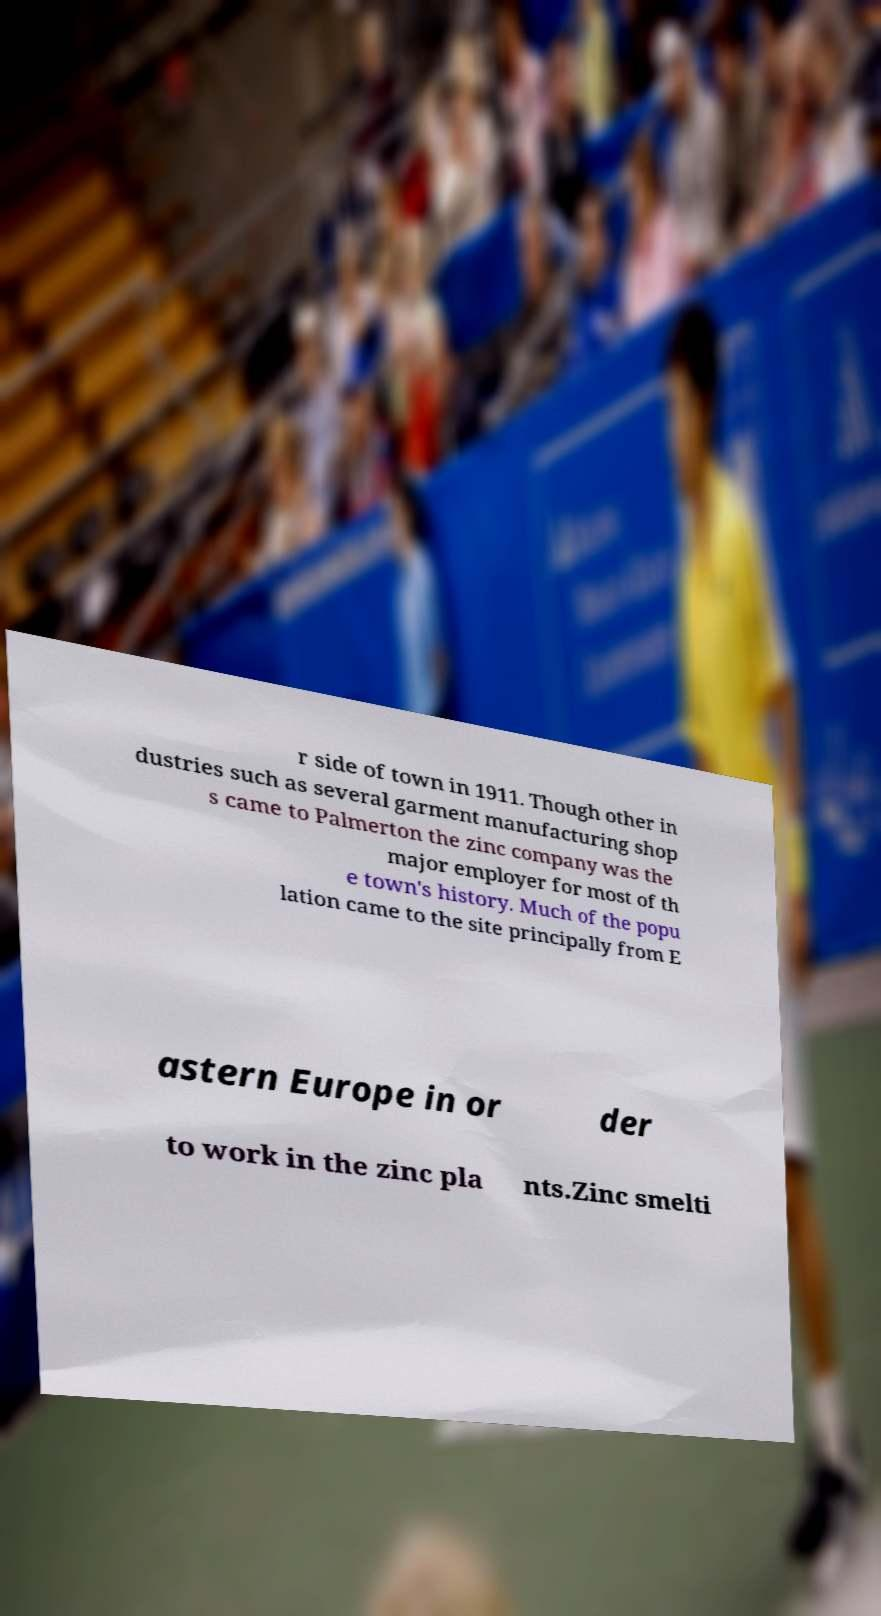There's text embedded in this image that I need extracted. Can you transcribe it verbatim? r side of town in 1911. Though other in dustries such as several garment manufacturing shop s came to Palmerton the zinc company was the major employer for most of th e town's history. Much of the popu lation came to the site principally from E astern Europe in or der to work in the zinc pla nts.Zinc smelti 